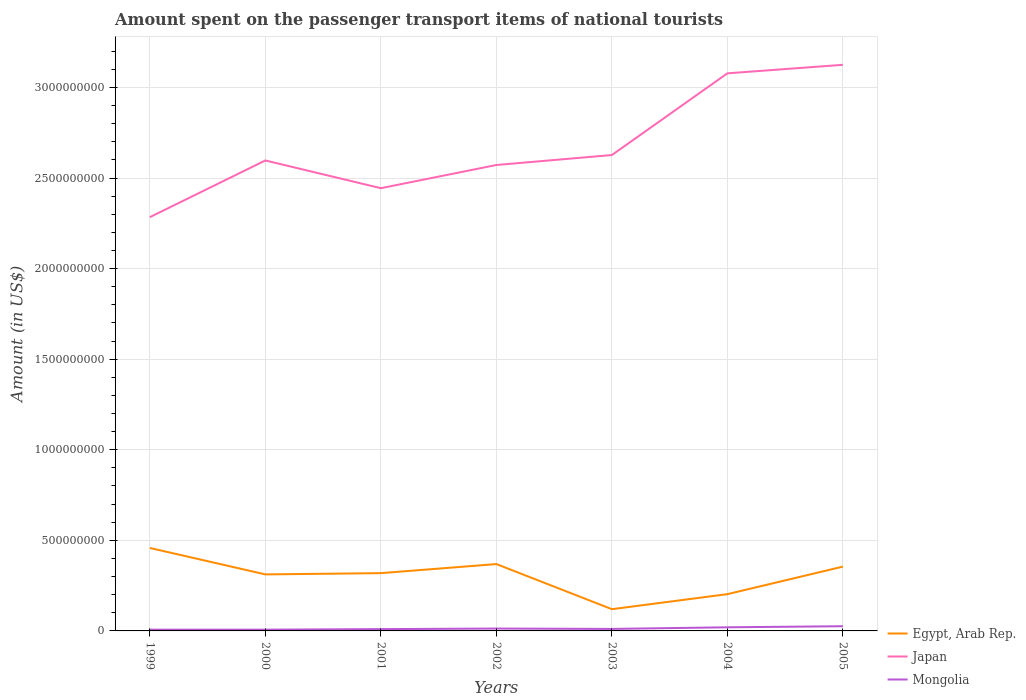Does the line corresponding to Japan intersect with the line corresponding to Mongolia?
Offer a terse response. No. Across all years, what is the maximum amount spent on the passenger transport items of national tourists in Mongolia?
Give a very brief answer. 7.00e+06. In which year was the amount spent on the passenger transport items of national tourists in Mongolia maximum?
Offer a terse response. 1999. What is the total amount spent on the passenger transport items of national tourists in Mongolia in the graph?
Give a very brief answer. -3.00e+06. What is the difference between the highest and the second highest amount spent on the passenger transport items of national tourists in Egypt, Arab Rep.?
Ensure brevity in your answer.  3.38e+08. What is the difference between the highest and the lowest amount spent on the passenger transport items of national tourists in Egypt, Arab Rep.?
Your response must be concise. 5. Are the values on the major ticks of Y-axis written in scientific E-notation?
Your answer should be compact. No. How many legend labels are there?
Give a very brief answer. 3. How are the legend labels stacked?
Your response must be concise. Vertical. What is the title of the graph?
Provide a short and direct response. Amount spent on the passenger transport items of national tourists. What is the label or title of the Y-axis?
Keep it short and to the point. Amount (in US$). What is the Amount (in US$) in Egypt, Arab Rep. in 1999?
Offer a terse response. 4.58e+08. What is the Amount (in US$) of Japan in 1999?
Provide a succinct answer. 2.28e+09. What is the Amount (in US$) of Egypt, Arab Rep. in 2000?
Provide a succinct answer. 3.12e+08. What is the Amount (in US$) in Japan in 2000?
Give a very brief answer. 2.60e+09. What is the Amount (in US$) of Egypt, Arab Rep. in 2001?
Give a very brief answer. 3.19e+08. What is the Amount (in US$) of Japan in 2001?
Provide a short and direct response. 2.44e+09. What is the Amount (in US$) of Egypt, Arab Rep. in 2002?
Ensure brevity in your answer.  3.69e+08. What is the Amount (in US$) in Japan in 2002?
Offer a terse response. 2.57e+09. What is the Amount (in US$) of Mongolia in 2002?
Your answer should be very brief. 1.30e+07. What is the Amount (in US$) in Egypt, Arab Rep. in 2003?
Your answer should be very brief. 1.20e+08. What is the Amount (in US$) of Japan in 2003?
Make the answer very short. 2.63e+09. What is the Amount (in US$) of Mongolia in 2003?
Your answer should be compact. 1.10e+07. What is the Amount (in US$) of Egypt, Arab Rep. in 2004?
Offer a terse response. 2.03e+08. What is the Amount (in US$) of Japan in 2004?
Offer a very short reply. 3.08e+09. What is the Amount (in US$) of Egypt, Arab Rep. in 2005?
Make the answer very short. 3.55e+08. What is the Amount (in US$) in Japan in 2005?
Your answer should be compact. 3.12e+09. What is the Amount (in US$) in Mongolia in 2005?
Provide a succinct answer. 2.60e+07. Across all years, what is the maximum Amount (in US$) in Egypt, Arab Rep.?
Your response must be concise. 4.58e+08. Across all years, what is the maximum Amount (in US$) in Japan?
Provide a succinct answer. 3.12e+09. Across all years, what is the maximum Amount (in US$) in Mongolia?
Offer a very short reply. 2.60e+07. Across all years, what is the minimum Amount (in US$) of Egypt, Arab Rep.?
Offer a terse response. 1.20e+08. Across all years, what is the minimum Amount (in US$) of Japan?
Your answer should be very brief. 2.28e+09. Across all years, what is the minimum Amount (in US$) of Mongolia?
Provide a succinct answer. 7.00e+06. What is the total Amount (in US$) of Egypt, Arab Rep. in the graph?
Make the answer very short. 2.14e+09. What is the total Amount (in US$) of Japan in the graph?
Ensure brevity in your answer.  1.87e+1. What is the total Amount (in US$) of Mongolia in the graph?
Provide a short and direct response. 9.40e+07. What is the difference between the Amount (in US$) in Egypt, Arab Rep. in 1999 and that in 2000?
Your response must be concise. 1.46e+08. What is the difference between the Amount (in US$) in Japan in 1999 and that in 2000?
Offer a very short reply. -3.13e+08. What is the difference between the Amount (in US$) of Mongolia in 1999 and that in 2000?
Your answer should be compact. 0. What is the difference between the Amount (in US$) in Egypt, Arab Rep. in 1999 and that in 2001?
Keep it short and to the point. 1.39e+08. What is the difference between the Amount (in US$) in Japan in 1999 and that in 2001?
Provide a succinct answer. -1.60e+08. What is the difference between the Amount (in US$) in Egypt, Arab Rep. in 1999 and that in 2002?
Your response must be concise. 8.90e+07. What is the difference between the Amount (in US$) in Japan in 1999 and that in 2002?
Make the answer very short. -2.88e+08. What is the difference between the Amount (in US$) of Mongolia in 1999 and that in 2002?
Ensure brevity in your answer.  -6.00e+06. What is the difference between the Amount (in US$) of Egypt, Arab Rep. in 1999 and that in 2003?
Ensure brevity in your answer.  3.38e+08. What is the difference between the Amount (in US$) in Japan in 1999 and that in 2003?
Your answer should be compact. -3.43e+08. What is the difference between the Amount (in US$) of Mongolia in 1999 and that in 2003?
Make the answer very short. -4.00e+06. What is the difference between the Amount (in US$) of Egypt, Arab Rep. in 1999 and that in 2004?
Make the answer very short. 2.55e+08. What is the difference between the Amount (in US$) of Japan in 1999 and that in 2004?
Keep it short and to the point. -7.94e+08. What is the difference between the Amount (in US$) in Mongolia in 1999 and that in 2004?
Offer a very short reply. -1.30e+07. What is the difference between the Amount (in US$) in Egypt, Arab Rep. in 1999 and that in 2005?
Your answer should be very brief. 1.03e+08. What is the difference between the Amount (in US$) in Japan in 1999 and that in 2005?
Your answer should be compact. -8.41e+08. What is the difference between the Amount (in US$) in Mongolia in 1999 and that in 2005?
Offer a terse response. -1.90e+07. What is the difference between the Amount (in US$) of Egypt, Arab Rep. in 2000 and that in 2001?
Your response must be concise. -7.00e+06. What is the difference between the Amount (in US$) in Japan in 2000 and that in 2001?
Your answer should be very brief. 1.53e+08. What is the difference between the Amount (in US$) in Mongolia in 2000 and that in 2001?
Provide a succinct answer. -3.00e+06. What is the difference between the Amount (in US$) of Egypt, Arab Rep. in 2000 and that in 2002?
Keep it short and to the point. -5.70e+07. What is the difference between the Amount (in US$) in Japan in 2000 and that in 2002?
Keep it short and to the point. 2.50e+07. What is the difference between the Amount (in US$) in Mongolia in 2000 and that in 2002?
Your answer should be very brief. -6.00e+06. What is the difference between the Amount (in US$) in Egypt, Arab Rep. in 2000 and that in 2003?
Your answer should be compact. 1.92e+08. What is the difference between the Amount (in US$) of Japan in 2000 and that in 2003?
Give a very brief answer. -3.00e+07. What is the difference between the Amount (in US$) of Egypt, Arab Rep. in 2000 and that in 2004?
Give a very brief answer. 1.09e+08. What is the difference between the Amount (in US$) in Japan in 2000 and that in 2004?
Ensure brevity in your answer.  -4.81e+08. What is the difference between the Amount (in US$) of Mongolia in 2000 and that in 2004?
Your response must be concise. -1.30e+07. What is the difference between the Amount (in US$) of Egypt, Arab Rep. in 2000 and that in 2005?
Keep it short and to the point. -4.30e+07. What is the difference between the Amount (in US$) in Japan in 2000 and that in 2005?
Provide a short and direct response. -5.28e+08. What is the difference between the Amount (in US$) in Mongolia in 2000 and that in 2005?
Ensure brevity in your answer.  -1.90e+07. What is the difference between the Amount (in US$) of Egypt, Arab Rep. in 2001 and that in 2002?
Offer a very short reply. -5.00e+07. What is the difference between the Amount (in US$) of Japan in 2001 and that in 2002?
Your answer should be compact. -1.28e+08. What is the difference between the Amount (in US$) in Mongolia in 2001 and that in 2002?
Ensure brevity in your answer.  -3.00e+06. What is the difference between the Amount (in US$) in Egypt, Arab Rep. in 2001 and that in 2003?
Your response must be concise. 1.99e+08. What is the difference between the Amount (in US$) of Japan in 2001 and that in 2003?
Provide a succinct answer. -1.83e+08. What is the difference between the Amount (in US$) in Egypt, Arab Rep. in 2001 and that in 2004?
Make the answer very short. 1.16e+08. What is the difference between the Amount (in US$) of Japan in 2001 and that in 2004?
Provide a short and direct response. -6.34e+08. What is the difference between the Amount (in US$) of Mongolia in 2001 and that in 2004?
Your answer should be compact. -1.00e+07. What is the difference between the Amount (in US$) in Egypt, Arab Rep. in 2001 and that in 2005?
Your answer should be compact. -3.60e+07. What is the difference between the Amount (in US$) in Japan in 2001 and that in 2005?
Keep it short and to the point. -6.81e+08. What is the difference between the Amount (in US$) of Mongolia in 2001 and that in 2005?
Make the answer very short. -1.60e+07. What is the difference between the Amount (in US$) of Egypt, Arab Rep. in 2002 and that in 2003?
Keep it short and to the point. 2.49e+08. What is the difference between the Amount (in US$) of Japan in 2002 and that in 2003?
Give a very brief answer. -5.50e+07. What is the difference between the Amount (in US$) of Mongolia in 2002 and that in 2003?
Your answer should be very brief. 2.00e+06. What is the difference between the Amount (in US$) of Egypt, Arab Rep. in 2002 and that in 2004?
Provide a short and direct response. 1.66e+08. What is the difference between the Amount (in US$) in Japan in 2002 and that in 2004?
Make the answer very short. -5.06e+08. What is the difference between the Amount (in US$) in Mongolia in 2002 and that in 2004?
Offer a very short reply. -7.00e+06. What is the difference between the Amount (in US$) of Egypt, Arab Rep. in 2002 and that in 2005?
Your answer should be very brief. 1.40e+07. What is the difference between the Amount (in US$) in Japan in 2002 and that in 2005?
Your response must be concise. -5.53e+08. What is the difference between the Amount (in US$) in Mongolia in 2002 and that in 2005?
Your response must be concise. -1.30e+07. What is the difference between the Amount (in US$) of Egypt, Arab Rep. in 2003 and that in 2004?
Your response must be concise. -8.30e+07. What is the difference between the Amount (in US$) of Japan in 2003 and that in 2004?
Your response must be concise. -4.51e+08. What is the difference between the Amount (in US$) in Mongolia in 2003 and that in 2004?
Provide a short and direct response. -9.00e+06. What is the difference between the Amount (in US$) in Egypt, Arab Rep. in 2003 and that in 2005?
Make the answer very short. -2.35e+08. What is the difference between the Amount (in US$) of Japan in 2003 and that in 2005?
Make the answer very short. -4.98e+08. What is the difference between the Amount (in US$) of Mongolia in 2003 and that in 2005?
Make the answer very short. -1.50e+07. What is the difference between the Amount (in US$) in Egypt, Arab Rep. in 2004 and that in 2005?
Keep it short and to the point. -1.52e+08. What is the difference between the Amount (in US$) in Japan in 2004 and that in 2005?
Keep it short and to the point. -4.70e+07. What is the difference between the Amount (in US$) in Mongolia in 2004 and that in 2005?
Keep it short and to the point. -6.00e+06. What is the difference between the Amount (in US$) in Egypt, Arab Rep. in 1999 and the Amount (in US$) in Japan in 2000?
Make the answer very short. -2.14e+09. What is the difference between the Amount (in US$) of Egypt, Arab Rep. in 1999 and the Amount (in US$) of Mongolia in 2000?
Provide a short and direct response. 4.51e+08. What is the difference between the Amount (in US$) in Japan in 1999 and the Amount (in US$) in Mongolia in 2000?
Provide a short and direct response. 2.28e+09. What is the difference between the Amount (in US$) in Egypt, Arab Rep. in 1999 and the Amount (in US$) in Japan in 2001?
Provide a short and direct response. -1.99e+09. What is the difference between the Amount (in US$) in Egypt, Arab Rep. in 1999 and the Amount (in US$) in Mongolia in 2001?
Provide a short and direct response. 4.48e+08. What is the difference between the Amount (in US$) in Japan in 1999 and the Amount (in US$) in Mongolia in 2001?
Provide a short and direct response. 2.27e+09. What is the difference between the Amount (in US$) of Egypt, Arab Rep. in 1999 and the Amount (in US$) of Japan in 2002?
Your answer should be very brief. -2.11e+09. What is the difference between the Amount (in US$) in Egypt, Arab Rep. in 1999 and the Amount (in US$) in Mongolia in 2002?
Make the answer very short. 4.45e+08. What is the difference between the Amount (in US$) of Japan in 1999 and the Amount (in US$) of Mongolia in 2002?
Your response must be concise. 2.27e+09. What is the difference between the Amount (in US$) in Egypt, Arab Rep. in 1999 and the Amount (in US$) in Japan in 2003?
Keep it short and to the point. -2.17e+09. What is the difference between the Amount (in US$) of Egypt, Arab Rep. in 1999 and the Amount (in US$) of Mongolia in 2003?
Offer a terse response. 4.47e+08. What is the difference between the Amount (in US$) of Japan in 1999 and the Amount (in US$) of Mongolia in 2003?
Keep it short and to the point. 2.27e+09. What is the difference between the Amount (in US$) of Egypt, Arab Rep. in 1999 and the Amount (in US$) of Japan in 2004?
Make the answer very short. -2.62e+09. What is the difference between the Amount (in US$) in Egypt, Arab Rep. in 1999 and the Amount (in US$) in Mongolia in 2004?
Provide a short and direct response. 4.38e+08. What is the difference between the Amount (in US$) in Japan in 1999 and the Amount (in US$) in Mongolia in 2004?
Ensure brevity in your answer.  2.26e+09. What is the difference between the Amount (in US$) in Egypt, Arab Rep. in 1999 and the Amount (in US$) in Japan in 2005?
Ensure brevity in your answer.  -2.67e+09. What is the difference between the Amount (in US$) in Egypt, Arab Rep. in 1999 and the Amount (in US$) in Mongolia in 2005?
Ensure brevity in your answer.  4.32e+08. What is the difference between the Amount (in US$) in Japan in 1999 and the Amount (in US$) in Mongolia in 2005?
Offer a very short reply. 2.26e+09. What is the difference between the Amount (in US$) in Egypt, Arab Rep. in 2000 and the Amount (in US$) in Japan in 2001?
Offer a terse response. -2.13e+09. What is the difference between the Amount (in US$) in Egypt, Arab Rep. in 2000 and the Amount (in US$) in Mongolia in 2001?
Offer a terse response. 3.02e+08. What is the difference between the Amount (in US$) of Japan in 2000 and the Amount (in US$) of Mongolia in 2001?
Provide a succinct answer. 2.59e+09. What is the difference between the Amount (in US$) in Egypt, Arab Rep. in 2000 and the Amount (in US$) in Japan in 2002?
Provide a succinct answer. -2.26e+09. What is the difference between the Amount (in US$) in Egypt, Arab Rep. in 2000 and the Amount (in US$) in Mongolia in 2002?
Keep it short and to the point. 2.99e+08. What is the difference between the Amount (in US$) of Japan in 2000 and the Amount (in US$) of Mongolia in 2002?
Give a very brief answer. 2.58e+09. What is the difference between the Amount (in US$) of Egypt, Arab Rep. in 2000 and the Amount (in US$) of Japan in 2003?
Provide a short and direct response. -2.32e+09. What is the difference between the Amount (in US$) of Egypt, Arab Rep. in 2000 and the Amount (in US$) of Mongolia in 2003?
Offer a very short reply. 3.01e+08. What is the difference between the Amount (in US$) in Japan in 2000 and the Amount (in US$) in Mongolia in 2003?
Your answer should be very brief. 2.59e+09. What is the difference between the Amount (in US$) of Egypt, Arab Rep. in 2000 and the Amount (in US$) of Japan in 2004?
Provide a succinct answer. -2.77e+09. What is the difference between the Amount (in US$) of Egypt, Arab Rep. in 2000 and the Amount (in US$) of Mongolia in 2004?
Keep it short and to the point. 2.92e+08. What is the difference between the Amount (in US$) in Japan in 2000 and the Amount (in US$) in Mongolia in 2004?
Your response must be concise. 2.58e+09. What is the difference between the Amount (in US$) in Egypt, Arab Rep. in 2000 and the Amount (in US$) in Japan in 2005?
Ensure brevity in your answer.  -2.81e+09. What is the difference between the Amount (in US$) of Egypt, Arab Rep. in 2000 and the Amount (in US$) of Mongolia in 2005?
Keep it short and to the point. 2.86e+08. What is the difference between the Amount (in US$) in Japan in 2000 and the Amount (in US$) in Mongolia in 2005?
Provide a short and direct response. 2.57e+09. What is the difference between the Amount (in US$) of Egypt, Arab Rep. in 2001 and the Amount (in US$) of Japan in 2002?
Your answer should be compact. -2.25e+09. What is the difference between the Amount (in US$) of Egypt, Arab Rep. in 2001 and the Amount (in US$) of Mongolia in 2002?
Provide a succinct answer. 3.06e+08. What is the difference between the Amount (in US$) in Japan in 2001 and the Amount (in US$) in Mongolia in 2002?
Make the answer very short. 2.43e+09. What is the difference between the Amount (in US$) of Egypt, Arab Rep. in 2001 and the Amount (in US$) of Japan in 2003?
Provide a short and direct response. -2.31e+09. What is the difference between the Amount (in US$) in Egypt, Arab Rep. in 2001 and the Amount (in US$) in Mongolia in 2003?
Your response must be concise. 3.08e+08. What is the difference between the Amount (in US$) of Japan in 2001 and the Amount (in US$) of Mongolia in 2003?
Your answer should be very brief. 2.43e+09. What is the difference between the Amount (in US$) in Egypt, Arab Rep. in 2001 and the Amount (in US$) in Japan in 2004?
Give a very brief answer. -2.76e+09. What is the difference between the Amount (in US$) in Egypt, Arab Rep. in 2001 and the Amount (in US$) in Mongolia in 2004?
Make the answer very short. 2.99e+08. What is the difference between the Amount (in US$) in Japan in 2001 and the Amount (in US$) in Mongolia in 2004?
Provide a short and direct response. 2.42e+09. What is the difference between the Amount (in US$) in Egypt, Arab Rep. in 2001 and the Amount (in US$) in Japan in 2005?
Your answer should be compact. -2.81e+09. What is the difference between the Amount (in US$) in Egypt, Arab Rep. in 2001 and the Amount (in US$) in Mongolia in 2005?
Make the answer very short. 2.93e+08. What is the difference between the Amount (in US$) of Japan in 2001 and the Amount (in US$) of Mongolia in 2005?
Your response must be concise. 2.42e+09. What is the difference between the Amount (in US$) of Egypt, Arab Rep. in 2002 and the Amount (in US$) of Japan in 2003?
Offer a terse response. -2.26e+09. What is the difference between the Amount (in US$) of Egypt, Arab Rep. in 2002 and the Amount (in US$) of Mongolia in 2003?
Provide a succinct answer. 3.58e+08. What is the difference between the Amount (in US$) in Japan in 2002 and the Amount (in US$) in Mongolia in 2003?
Make the answer very short. 2.56e+09. What is the difference between the Amount (in US$) in Egypt, Arab Rep. in 2002 and the Amount (in US$) in Japan in 2004?
Ensure brevity in your answer.  -2.71e+09. What is the difference between the Amount (in US$) in Egypt, Arab Rep. in 2002 and the Amount (in US$) in Mongolia in 2004?
Your answer should be very brief. 3.49e+08. What is the difference between the Amount (in US$) of Japan in 2002 and the Amount (in US$) of Mongolia in 2004?
Your answer should be compact. 2.55e+09. What is the difference between the Amount (in US$) in Egypt, Arab Rep. in 2002 and the Amount (in US$) in Japan in 2005?
Provide a succinct answer. -2.76e+09. What is the difference between the Amount (in US$) of Egypt, Arab Rep. in 2002 and the Amount (in US$) of Mongolia in 2005?
Offer a very short reply. 3.43e+08. What is the difference between the Amount (in US$) of Japan in 2002 and the Amount (in US$) of Mongolia in 2005?
Your response must be concise. 2.55e+09. What is the difference between the Amount (in US$) of Egypt, Arab Rep. in 2003 and the Amount (in US$) of Japan in 2004?
Keep it short and to the point. -2.96e+09. What is the difference between the Amount (in US$) of Japan in 2003 and the Amount (in US$) of Mongolia in 2004?
Make the answer very short. 2.61e+09. What is the difference between the Amount (in US$) of Egypt, Arab Rep. in 2003 and the Amount (in US$) of Japan in 2005?
Keep it short and to the point. -3.00e+09. What is the difference between the Amount (in US$) of Egypt, Arab Rep. in 2003 and the Amount (in US$) of Mongolia in 2005?
Offer a very short reply. 9.40e+07. What is the difference between the Amount (in US$) in Japan in 2003 and the Amount (in US$) in Mongolia in 2005?
Your answer should be very brief. 2.60e+09. What is the difference between the Amount (in US$) of Egypt, Arab Rep. in 2004 and the Amount (in US$) of Japan in 2005?
Offer a terse response. -2.92e+09. What is the difference between the Amount (in US$) of Egypt, Arab Rep. in 2004 and the Amount (in US$) of Mongolia in 2005?
Offer a terse response. 1.77e+08. What is the difference between the Amount (in US$) of Japan in 2004 and the Amount (in US$) of Mongolia in 2005?
Your answer should be compact. 3.05e+09. What is the average Amount (in US$) in Egypt, Arab Rep. per year?
Offer a very short reply. 3.05e+08. What is the average Amount (in US$) in Japan per year?
Your answer should be compact. 2.68e+09. What is the average Amount (in US$) of Mongolia per year?
Offer a terse response. 1.34e+07. In the year 1999, what is the difference between the Amount (in US$) of Egypt, Arab Rep. and Amount (in US$) of Japan?
Your response must be concise. -1.83e+09. In the year 1999, what is the difference between the Amount (in US$) in Egypt, Arab Rep. and Amount (in US$) in Mongolia?
Provide a succinct answer. 4.51e+08. In the year 1999, what is the difference between the Amount (in US$) in Japan and Amount (in US$) in Mongolia?
Ensure brevity in your answer.  2.28e+09. In the year 2000, what is the difference between the Amount (in US$) of Egypt, Arab Rep. and Amount (in US$) of Japan?
Provide a short and direct response. -2.28e+09. In the year 2000, what is the difference between the Amount (in US$) in Egypt, Arab Rep. and Amount (in US$) in Mongolia?
Give a very brief answer. 3.05e+08. In the year 2000, what is the difference between the Amount (in US$) of Japan and Amount (in US$) of Mongolia?
Provide a succinct answer. 2.59e+09. In the year 2001, what is the difference between the Amount (in US$) of Egypt, Arab Rep. and Amount (in US$) of Japan?
Provide a short and direct response. -2.12e+09. In the year 2001, what is the difference between the Amount (in US$) in Egypt, Arab Rep. and Amount (in US$) in Mongolia?
Ensure brevity in your answer.  3.09e+08. In the year 2001, what is the difference between the Amount (in US$) of Japan and Amount (in US$) of Mongolia?
Offer a terse response. 2.43e+09. In the year 2002, what is the difference between the Amount (in US$) in Egypt, Arab Rep. and Amount (in US$) in Japan?
Keep it short and to the point. -2.20e+09. In the year 2002, what is the difference between the Amount (in US$) in Egypt, Arab Rep. and Amount (in US$) in Mongolia?
Ensure brevity in your answer.  3.56e+08. In the year 2002, what is the difference between the Amount (in US$) of Japan and Amount (in US$) of Mongolia?
Ensure brevity in your answer.  2.56e+09. In the year 2003, what is the difference between the Amount (in US$) in Egypt, Arab Rep. and Amount (in US$) in Japan?
Provide a short and direct response. -2.51e+09. In the year 2003, what is the difference between the Amount (in US$) of Egypt, Arab Rep. and Amount (in US$) of Mongolia?
Offer a terse response. 1.09e+08. In the year 2003, what is the difference between the Amount (in US$) in Japan and Amount (in US$) in Mongolia?
Make the answer very short. 2.62e+09. In the year 2004, what is the difference between the Amount (in US$) in Egypt, Arab Rep. and Amount (in US$) in Japan?
Offer a very short reply. -2.88e+09. In the year 2004, what is the difference between the Amount (in US$) in Egypt, Arab Rep. and Amount (in US$) in Mongolia?
Offer a terse response. 1.83e+08. In the year 2004, what is the difference between the Amount (in US$) of Japan and Amount (in US$) of Mongolia?
Provide a succinct answer. 3.06e+09. In the year 2005, what is the difference between the Amount (in US$) in Egypt, Arab Rep. and Amount (in US$) in Japan?
Make the answer very short. -2.77e+09. In the year 2005, what is the difference between the Amount (in US$) in Egypt, Arab Rep. and Amount (in US$) in Mongolia?
Your response must be concise. 3.29e+08. In the year 2005, what is the difference between the Amount (in US$) of Japan and Amount (in US$) of Mongolia?
Make the answer very short. 3.10e+09. What is the ratio of the Amount (in US$) in Egypt, Arab Rep. in 1999 to that in 2000?
Offer a very short reply. 1.47. What is the ratio of the Amount (in US$) in Japan in 1999 to that in 2000?
Provide a succinct answer. 0.88. What is the ratio of the Amount (in US$) of Egypt, Arab Rep. in 1999 to that in 2001?
Make the answer very short. 1.44. What is the ratio of the Amount (in US$) in Japan in 1999 to that in 2001?
Make the answer very short. 0.93. What is the ratio of the Amount (in US$) of Mongolia in 1999 to that in 2001?
Ensure brevity in your answer.  0.7. What is the ratio of the Amount (in US$) of Egypt, Arab Rep. in 1999 to that in 2002?
Your answer should be very brief. 1.24. What is the ratio of the Amount (in US$) of Japan in 1999 to that in 2002?
Offer a terse response. 0.89. What is the ratio of the Amount (in US$) in Mongolia in 1999 to that in 2002?
Ensure brevity in your answer.  0.54. What is the ratio of the Amount (in US$) of Egypt, Arab Rep. in 1999 to that in 2003?
Keep it short and to the point. 3.82. What is the ratio of the Amount (in US$) in Japan in 1999 to that in 2003?
Your answer should be compact. 0.87. What is the ratio of the Amount (in US$) of Mongolia in 1999 to that in 2003?
Provide a short and direct response. 0.64. What is the ratio of the Amount (in US$) in Egypt, Arab Rep. in 1999 to that in 2004?
Provide a succinct answer. 2.26. What is the ratio of the Amount (in US$) in Japan in 1999 to that in 2004?
Offer a very short reply. 0.74. What is the ratio of the Amount (in US$) of Mongolia in 1999 to that in 2004?
Your answer should be compact. 0.35. What is the ratio of the Amount (in US$) of Egypt, Arab Rep. in 1999 to that in 2005?
Offer a very short reply. 1.29. What is the ratio of the Amount (in US$) in Japan in 1999 to that in 2005?
Ensure brevity in your answer.  0.73. What is the ratio of the Amount (in US$) in Mongolia in 1999 to that in 2005?
Your answer should be compact. 0.27. What is the ratio of the Amount (in US$) in Egypt, Arab Rep. in 2000 to that in 2001?
Make the answer very short. 0.98. What is the ratio of the Amount (in US$) in Japan in 2000 to that in 2001?
Your answer should be very brief. 1.06. What is the ratio of the Amount (in US$) of Mongolia in 2000 to that in 2001?
Your answer should be compact. 0.7. What is the ratio of the Amount (in US$) of Egypt, Arab Rep. in 2000 to that in 2002?
Your response must be concise. 0.85. What is the ratio of the Amount (in US$) in Japan in 2000 to that in 2002?
Offer a very short reply. 1.01. What is the ratio of the Amount (in US$) in Mongolia in 2000 to that in 2002?
Make the answer very short. 0.54. What is the ratio of the Amount (in US$) of Japan in 2000 to that in 2003?
Keep it short and to the point. 0.99. What is the ratio of the Amount (in US$) of Mongolia in 2000 to that in 2003?
Provide a short and direct response. 0.64. What is the ratio of the Amount (in US$) in Egypt, Arab Rep. in 2000 to that in 2004?
Provide a succinct answer. 1.54. What is the ratio of the Amount (in US$) in Japan in 2000 to that in 2004?
Keep it short and to the point. 0.84. What is the ratio of the Amount (in US$) of Egypt, Arab Rep. in 2000 to that in 2005?
Make the answer very short. 0.88. What is the ratio of the Amount (in US$) of Japan in 2000 to that in 2005?
Keep it short and to the point. 0.83. What is the ratio of the Amount (in US$) of Mongolia in 2000 to that in 2005?
Ensure brevity in your answer.  0.27. What is the ratio of the Amount (in US$) in Egypt, Arab Rep. in 2001 to that in 2002?
Provide a short and direct response. 0.86. What is the ratio of the Amount (in US$) of Japan in 2001 to that in 2002?
Provide a short and direct response. 0.95. What is the ratio of the Amount (in US$) in Mongolia in 2001 to that in 2002?
Ensure brevity in your answer.  0.77. What is the ratio of the Amount (in US$) of Egypt, Arab Rep. in 2001 to that in 2003?
Offer a very short reply. 2.66. What is the ratio of the Amount (in US$) in Japan in 2001 to that in 2003?
Provide a short and direct response. 0.93. What is the ratio of the Amount (in US$) of Mongolia in 2001 to that in 2003?
Your answer should be compact. 0.91. What is the ratio of the Amount (in US$) in Egypt, Arab Rep. in 2001 to that in 2004?
Your response must be concise. 1.57. What is the ratio of the Amount (in US$) in Japan in 2001 to that in 2004?
Your response must be concise. 0.79. What is the ratio of the Amount (in US$) in Egypt, Arab Rep. in 2001 to that in 2005?
Keep it short and to the point. 0.9. What is the ratio of the Amount (in US$) of Japan in 2001 to that in 2005?
Provide a short and direct response. 0.78. What is the ratio of the Amount (in US$) in Mongolia in 2001 to that in 2005?
Your response must be concise. 0.38. What is the ratio of the Amount (in US$) of Egypt, Arab Rep. in 2002 to that in 2003?
Your response must be concise. 3.08. What is the ratio of the Amount (in US$) in Japan in 2002 to that in 2003?
Make the answer very short. 0.98. What is the ratio of the Amount (in US$) in Mongolia in 2002 to that in 2003?
Provide a succinct answer. 1.18. What is the ratio of the Amount (in US$) of Egypt, Arab Rep. in 2002 to that in 2004?
Provide a succinct answer. 1.82. What is the ratio of the Amount (in US$) in Japan in 2002 to that in 2004?
Your answer should be compact. 0.84. What is the ratio of the Amount (in US$) of Mongolia in 2002 to that in 2004?
Ensure brevity in your answer.  0.65. What is the ratio of the Amount (in US$) in Egypt, Arab Rep. in 2002 to that in 2005?
Your response must be concise. 1.04. What is the ratio of the Amount (in US$) of Japan in 2002 to that in 2005?
Keep it short and to the point. 0.82. What is the ratio of the Amount (in US$) in Mongolia in 2002 to that in 2005?
Provide a succinct answer. 0.5. What is the ratio of the Amount (in US$) of Egypt, Arab Rep. in 2003 to that in 2004?
Keep it short and to the point. 0.59. What is the ratio of the Amount (in US$) in Japan in 2003 to that in 2004?
Your response must be concise. 0.85. What is the ratio of the Amount (in US$) in Mongolia in 2003 to that in 2004?
Provide a succinct answer. 0.55. What is the ratio of the Amount (in US$) in Egypt, Arab Rep. in 2003 to that in 2005?
Your answer should be very brief. 0.34. What is the ratio of the Amount (in US$) of Japan in 2003 to that in 2005?
Ensure brevity in your answer.  0.84. What is the ratio of the Amount (in US$) of Mongolia in 2003 to that in 2005?
Offer a terse response. 0.42. What is the ratio of the Amount (in US$) of Egypt, Arab Rep. in 2004 to that in 2005?
Ensure brevity in your answer.  0.57. What is the ratio of the Amount (in US$) in Japan in 2004 to that in 2005?
Your answer should be compact. 0.98. What is the ratio of the Amount (in US$) in Mongolia in 2004 to that in 2005?
Your response must be concise. 0.77. What is the difference between the highest and the second highest Amount (in US$) in Egypt, Arab Rep.?
Offer a very short reply. 8.90e+07. What is the difference between the highest and the second highest Amount (in US$) in Japan?
Your answer should be very brief. 4.70e+07. What is the difference between the highest and the second highest Amount (in US$) of Mongolia?
Offer a terse response. 6.00e+06. What is the difference between the highest and the lowest Amount (in US$) in Egypt, Arab Rep.?
Make the answer very short. 3.38e+08. What is the difference between the highest and the lowest Amount (in US$) in Japan?
Offer a terse response. 8.41e+08. What is the difference between the highest and the lowest Amount (in US$) in Mongolia?
Offer a terse response. 1.90e+07. 